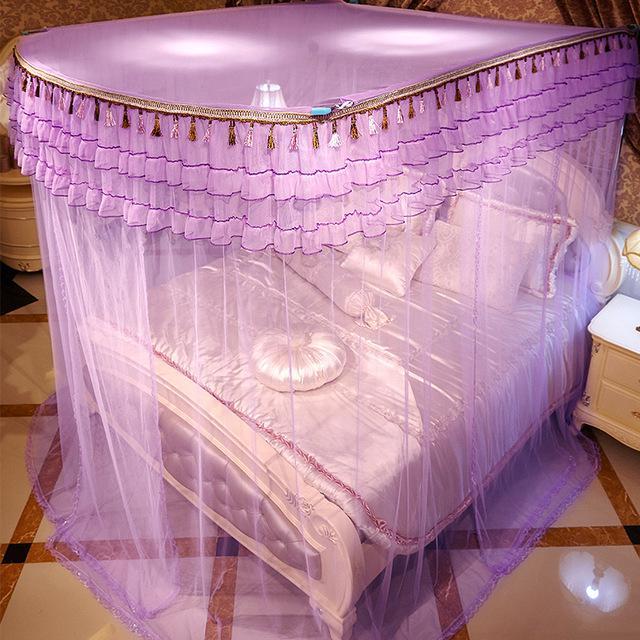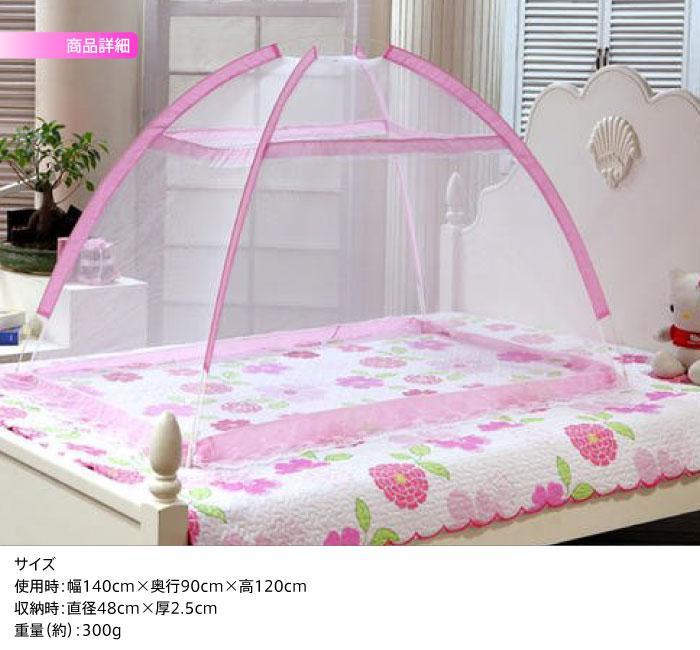The first image is the image on the left, the second image is the image on the right. Assess this claim about the two images: "Each image shows a bed with purple ruffled layers above it, and one of the images shows sheer purple draping at least two sides of the bed from a canopy the same shape as the bed.". Correct or not? Answer yes or no. No. 